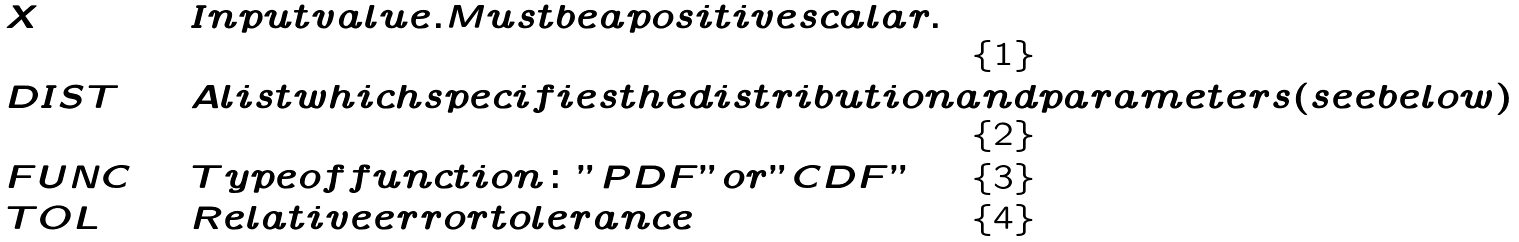<formula> <loc_0><loc_0><loc_500><loc_500>& X & \quad & I n p u t v a l u e . M u s t b e a p o s i t i v e s c a l a r . \\ & D I S T & \quad & A l i s t w h i c h s p e c i f i e s t h e d i s t r i b u t i o n a n d p a r a m e t e r s ( s e e b e l o w ) \\ & F U N C & \quad & T y p e o f f u n c t i o n \colon " P D F " o r " C D F " \\ & T O L & \quad & R e l a t i v e e r r o r t o l e r a n c e</formula> 